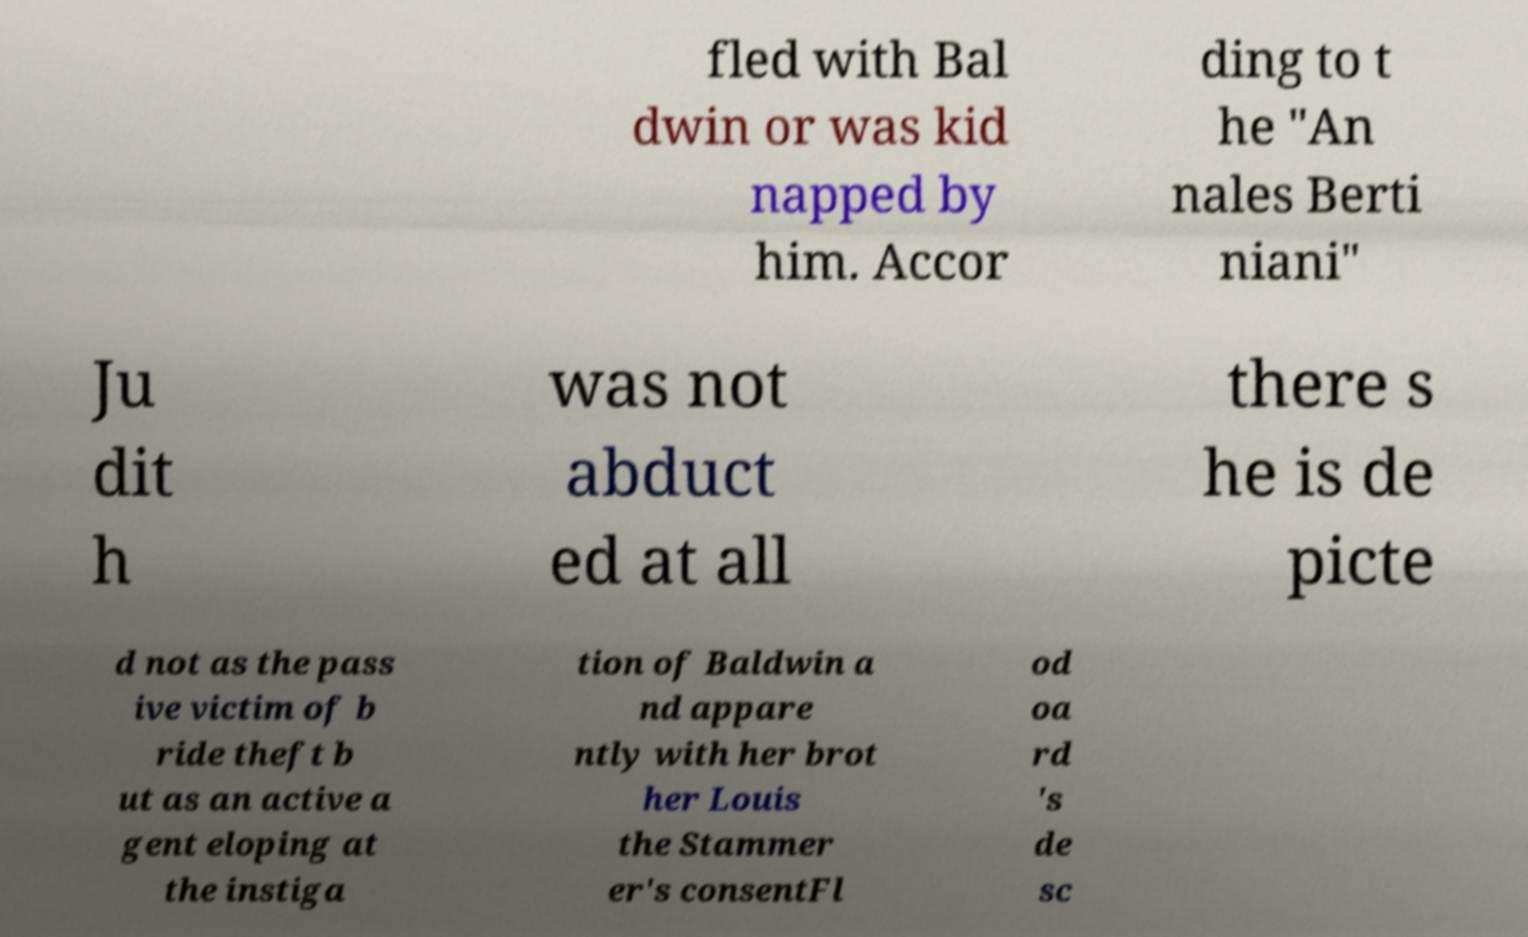Please read and relay the text visible in this image. What does it say? fled with Bal dwin or was kid napped by him. Accor ding to t he "An nales Berti niani" Ju dit h was not abduct ed at all there s he is de picte d not as the pass ive victim of b ride theft b ut as an active a gent eloping at the instiga tion of Baldwin a nd appare ntly with her brot her Louis the Stammer er's consentFl od oa rd 's de sc 